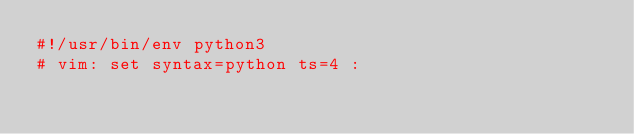<code> <loc_0><loc_0><loc_500><loc_500><_Python_>#!/usr/bin/env python3
# vim: set syntax=python ts=4 :</code> 